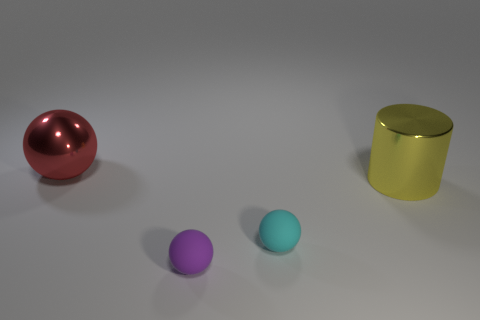Add 4 small purple matte things. How many objects exist? 8 Subtract all cylinders. How many objects are left? 3 Subtract 0 cyan cubes. How many objects are left? 4 Subtract all metal balls. Subtract all small green matte things. How many objects are left? 3 Add 1 large red metal objects. How many large red metal objects are left? 2 Add 4 large red spheres. How many large red spheres exist? 5 